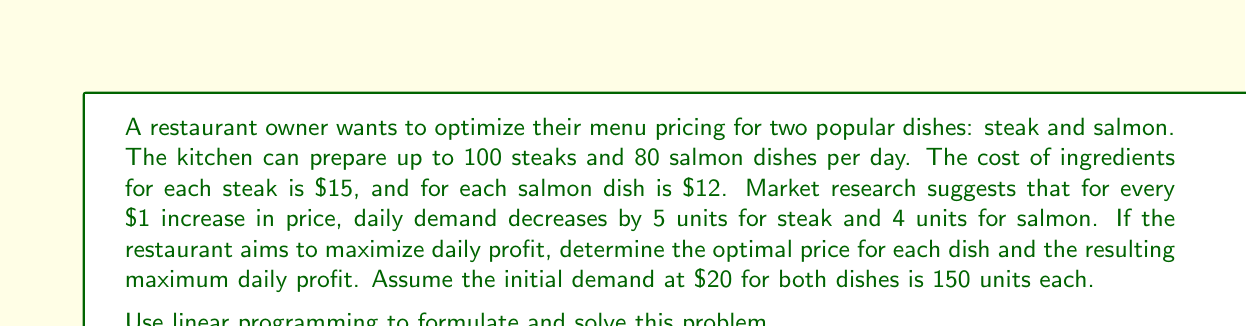Can you answer this question? Let's approach this step-by-step using linear programming:

1) Define variables:
   $x$ = price of steak
   $y$ = price of salmon

2) Formulate demand functions:
   Steak demand: $q_s = 250 - 5x$
   Salmon demand: $q_f = 230 - 4y$

3) Constraints:
   $q_s \leq 100$ (steak capacity)
   $q_f \leq 80$ (salmon capacity)
   $q_s, q_f \geq 0$ (non-negative demand)

4) Objective function (daily profit):
   $P = (x - 15)(250 - 5x) + (y - 12)(230 - 4y)$

5) Expand the objective function:
   $P = 250x - 5x^2 - 3750 + 230y - 4y^2 - 2760$
   $P = -5x^2 + 250x - 4y^2 + 230y - 6510$

6) To find the maximum, take partial derivatives and set to zero:
   $\frac{\partial P}{\partial x} = -10x + 250 = 0$
   $\frac{\partial P}{\partial y} = -8y + 230 = 0$

7) Solve these equations:
   $x = 25$
   $y = 28.75$

8) Check constraints:
   For steak: $q_s = 250 - 5(25) = 125$ > 100, so use 100
   For salmon: $q_f = 230 - 4(28.75) = 115$ > 80, so use 80

9) Adjust prices to meet constraints:
   For steak: $100 = 250 - 5x$, so $x = 30$
   For salmon: $80 = 230 - 4y$, so $y = 37.5$

10) Calculate maximum profit:
    $P = (30 - 15)(100) + (37.5 - 12)(80) = 1500 + 2040 = 3540$
Answer: The optimal price for steak is $30, and for salmon is $37.50. The maximum daily profit is $3,540. 